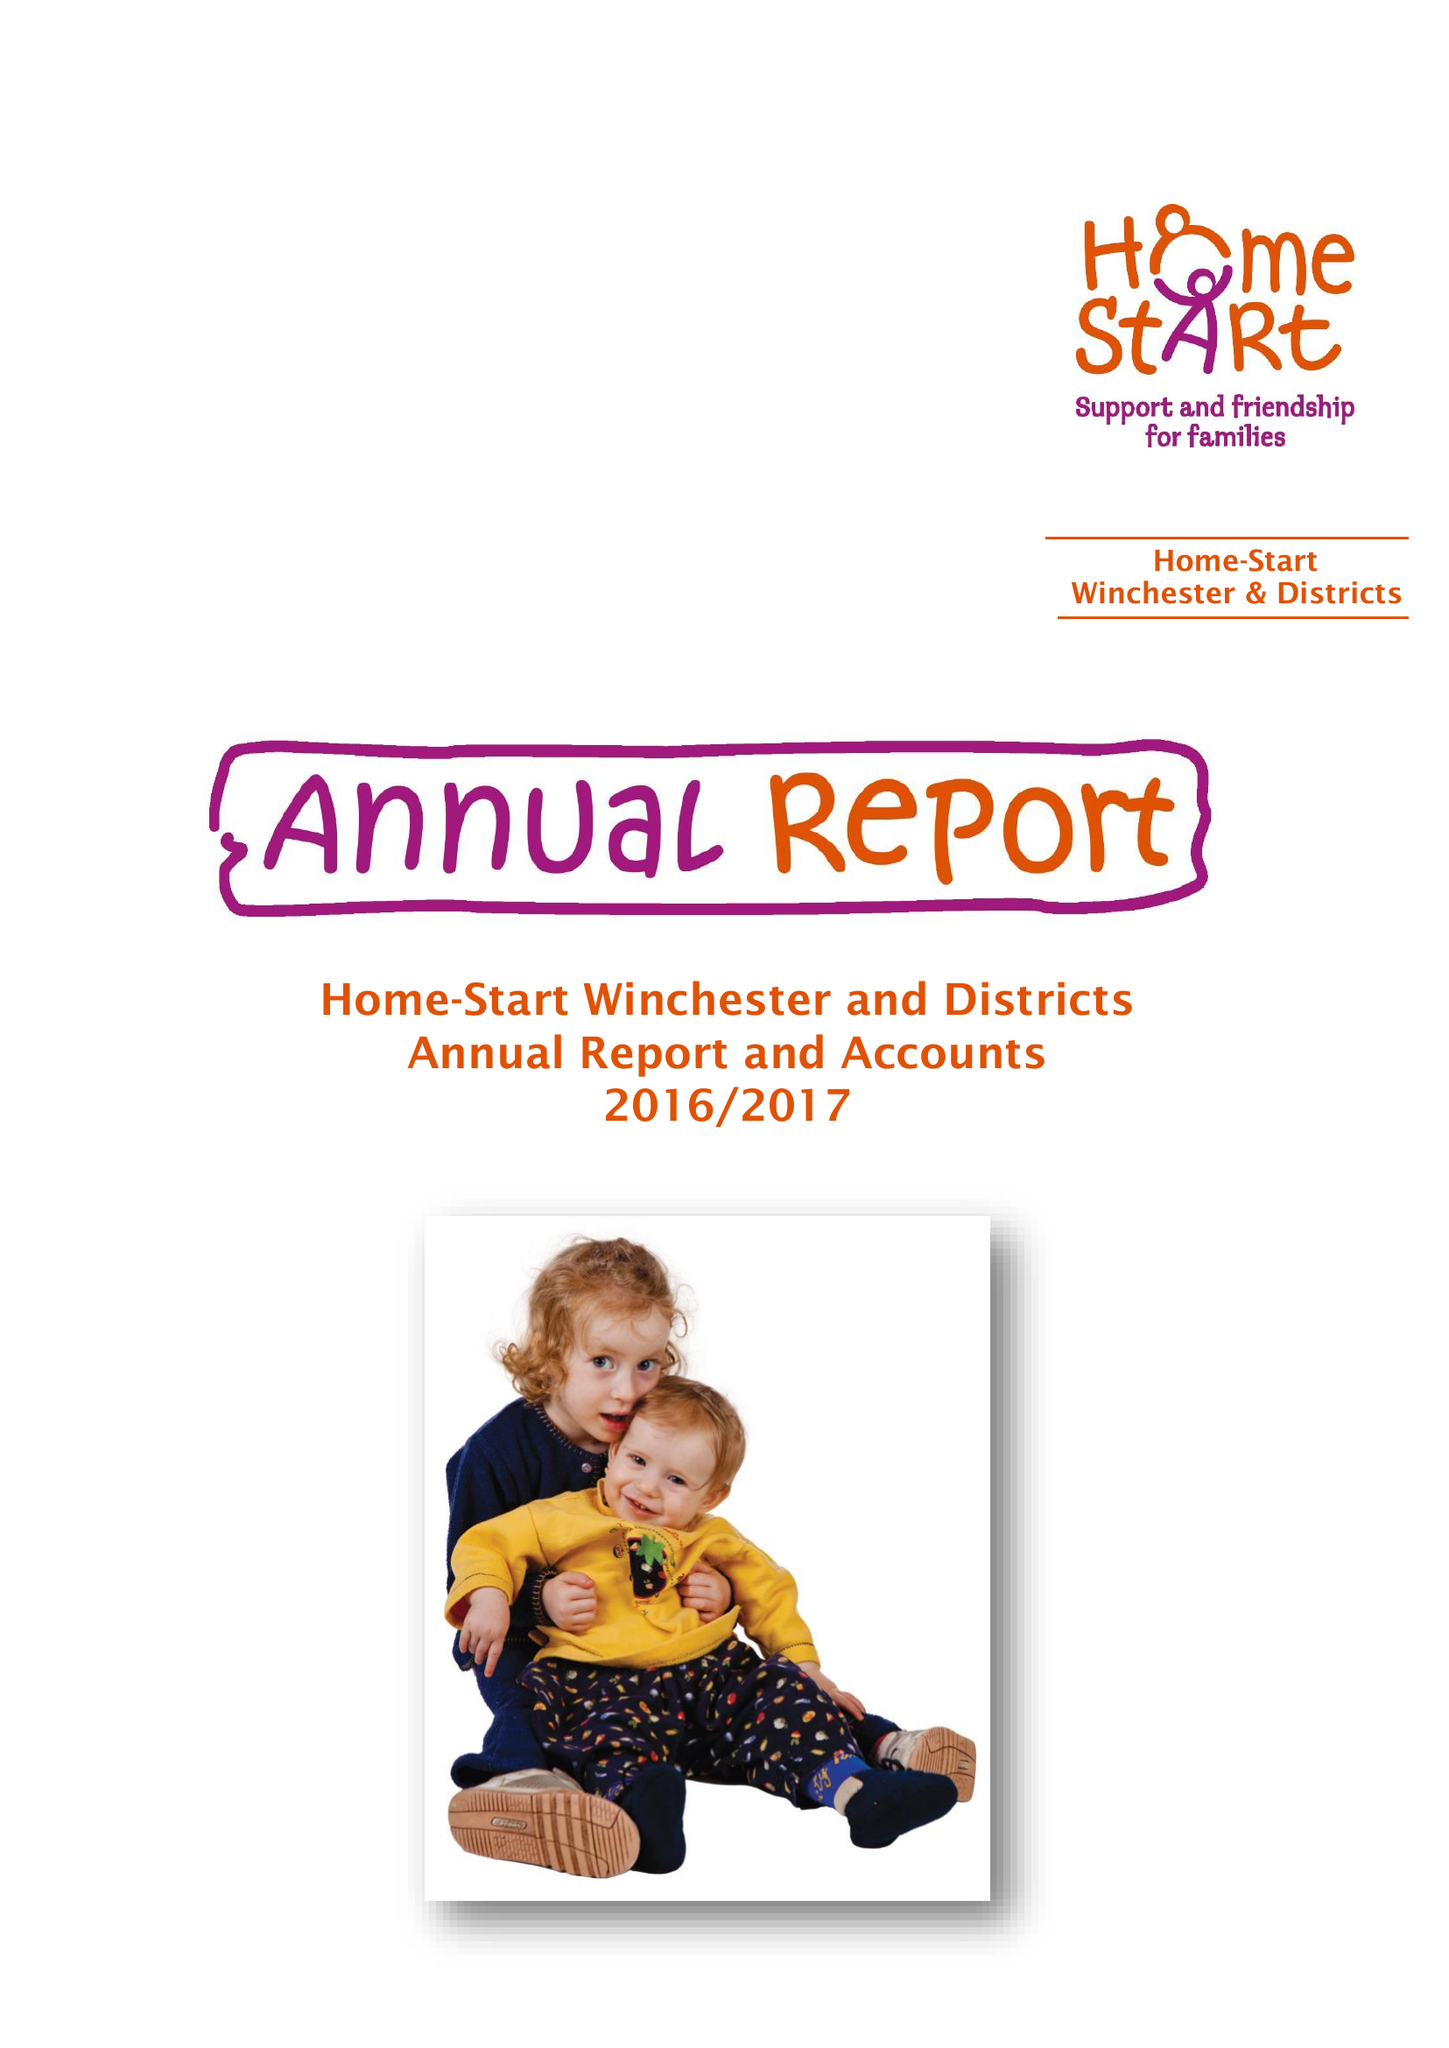What is the value for the report_date?
Answer the question using a single word or phrase. 2017-03-31 